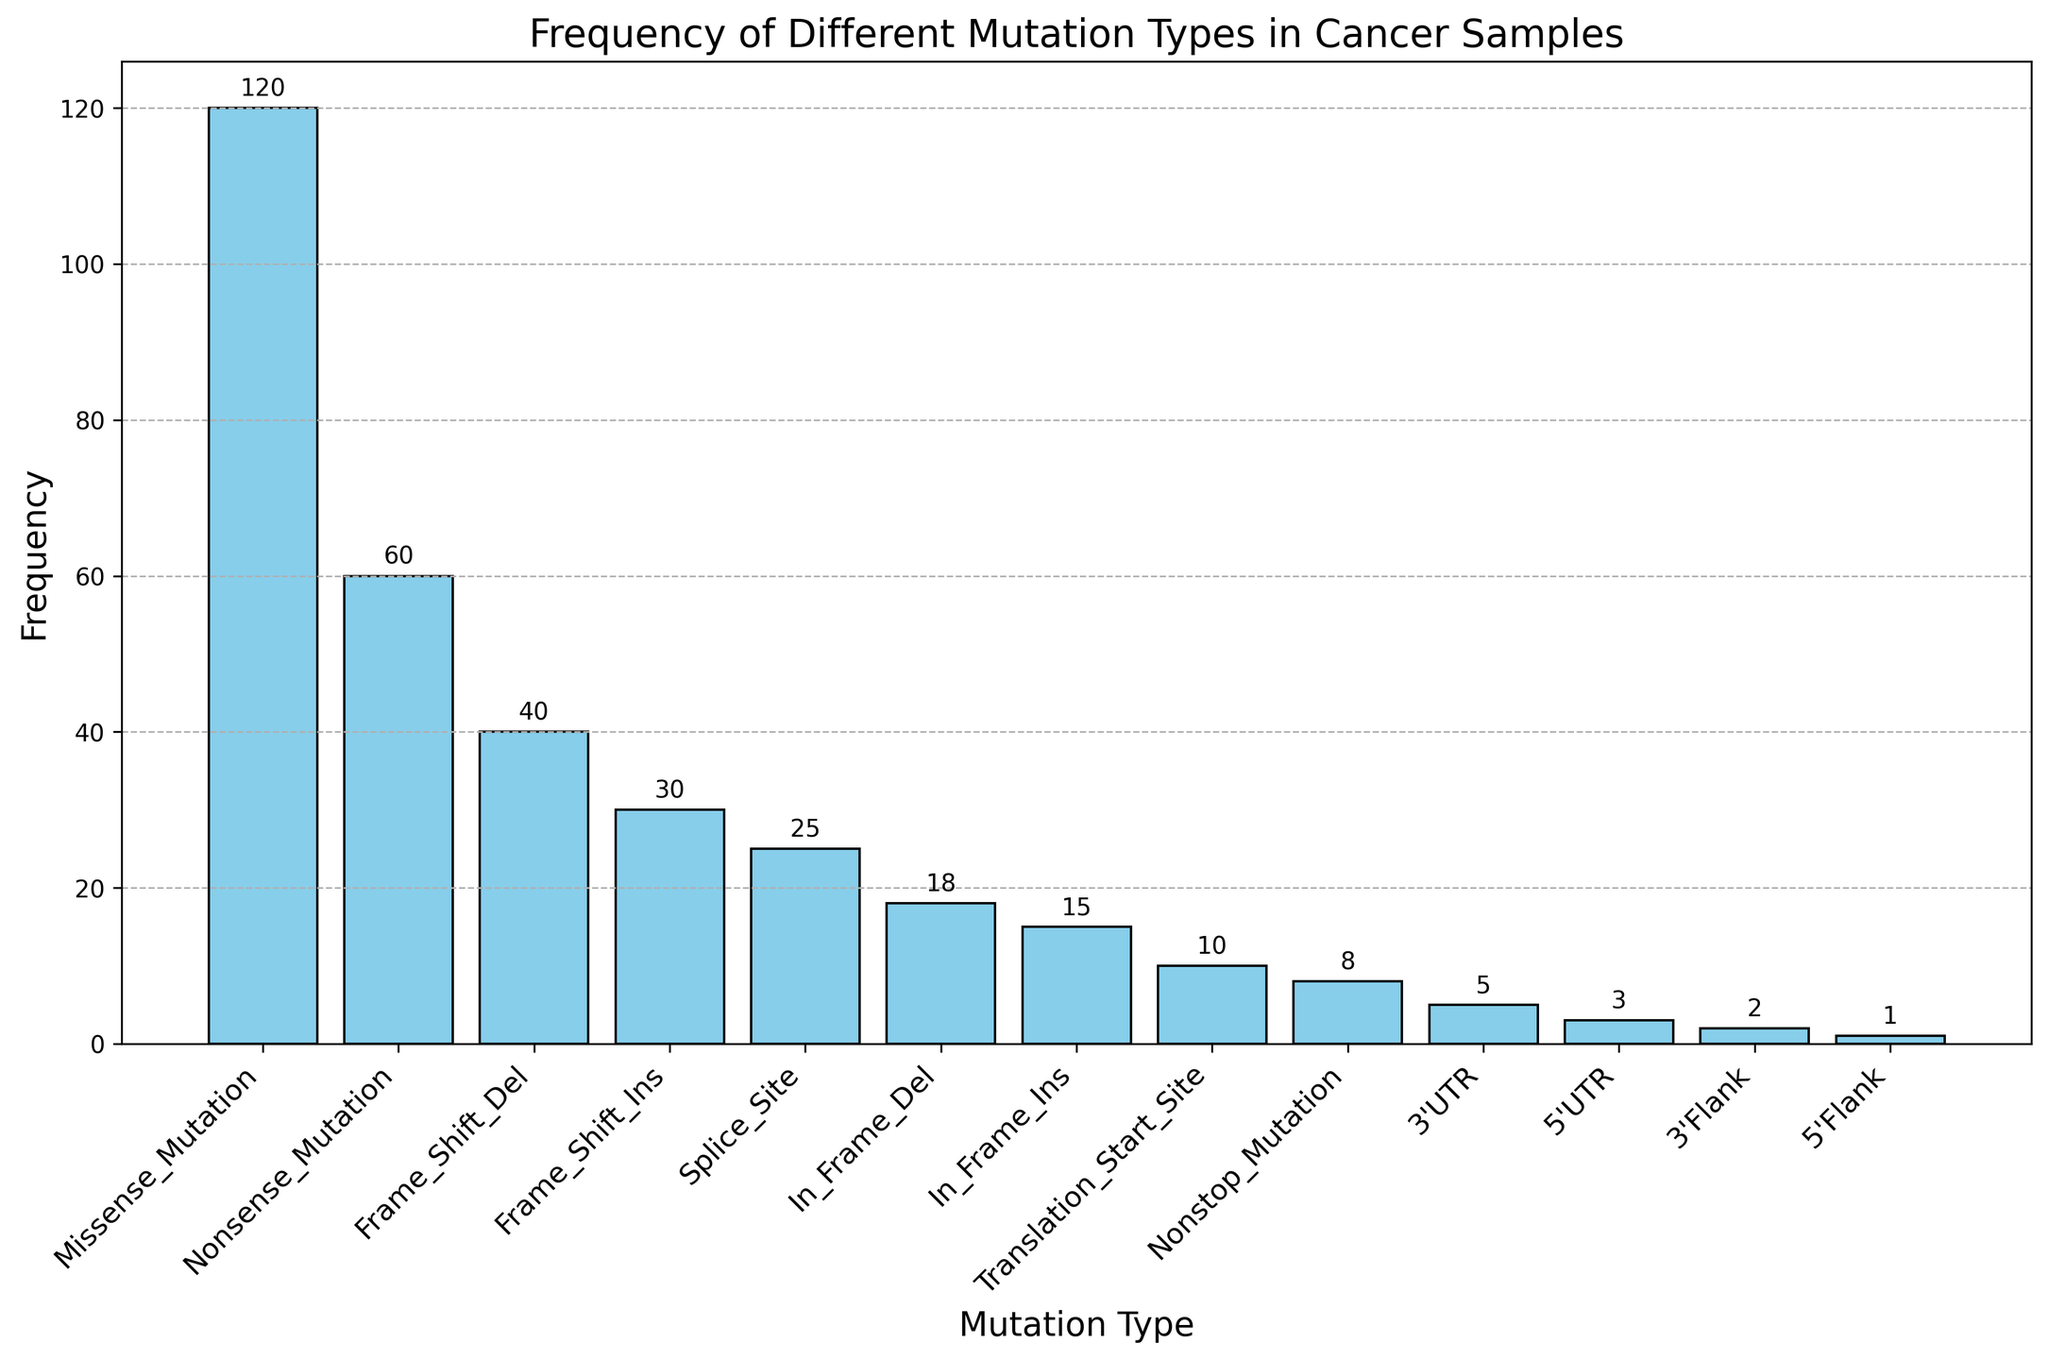What is the most frequent mutation type? By looking at the height of the bars, the tallest bar corresponds to the "Missense Mutation" which has a frequency of 120.
Answer: Missense Mutation What is the combined frequency of Missense Mutation and Nonsense Mutation? The height of the "Missense Mutation" bar is 120, and the "Nonsense Mutation" bar is 60. Summing these values gives 120 + 60 = 180.
Answer: 180 Which mutation type has a higher frequency: Splice Site or In Frame Ins? By comparing the heights of the bars, "Splice Site" has a height of 25 and "In Frame Ins" has a height of 15. 25 is greater than 15, so "Splice Site" has a higher frequency.
Answer: Splice Site How many mutation types have a frequency below 10? By counting the bars with heights less than 10, we find "Translation Start Site" (10), "Nonstop Mutation" (8), "3'UTR" (5), "5'UTR" (3), "3'Flank" (2), and "5'Flank" (1). There are 6 mutation types.
Answer: 6 What is the difference in frequency between Frame Shift Del and Frame Shift Ins? The height of the "Frame Shift Del" bar is 40, and the height of the "Frame Shift Ins" bar is 30. Subtracting these values gives 40 - 30 = 10.
Answer: 10 Which mutation type has the lowest frequency, and what is it? By looking at the bars, the shortest bar represents the "5' Flank" mutation type, which has a height of 1.
Answer: 5' Flank (1) What is the average frequency of the top three most frequent mutation types? The heights of the bars for the top three most frequent mutation types are "Missense Mutation" (120), "Nonsense Mutation" (60), and "Frame Shift Del" (40). Summing these gives 120 + 60 + 40 = 220. Dividing by 3, the average is 220 / 3 ≈ 73.33.
Answer: 73.33 